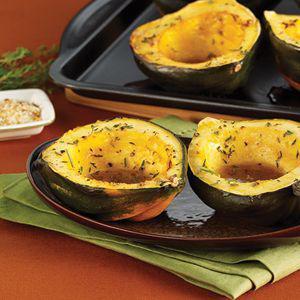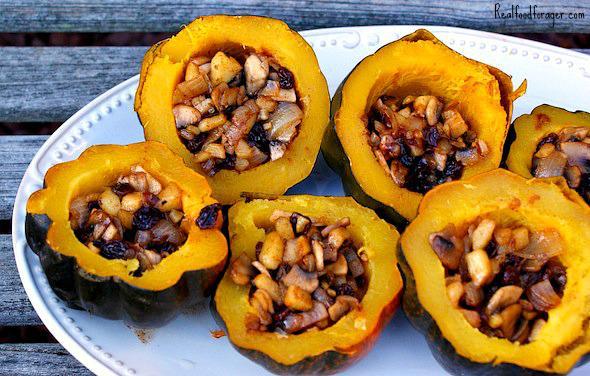The first image is the image on the left, the second image is the image on the right. Considering the images on both sides, is "The left image contains squash cut in half." valid? Answer yes or no. Yes. The first image is the image on the left, the second image is the image on the right. Given the left and right images, does the statement "Some of the squash in the image on the left sit on a black tray." hold true? Answer yes or no. Yes. 